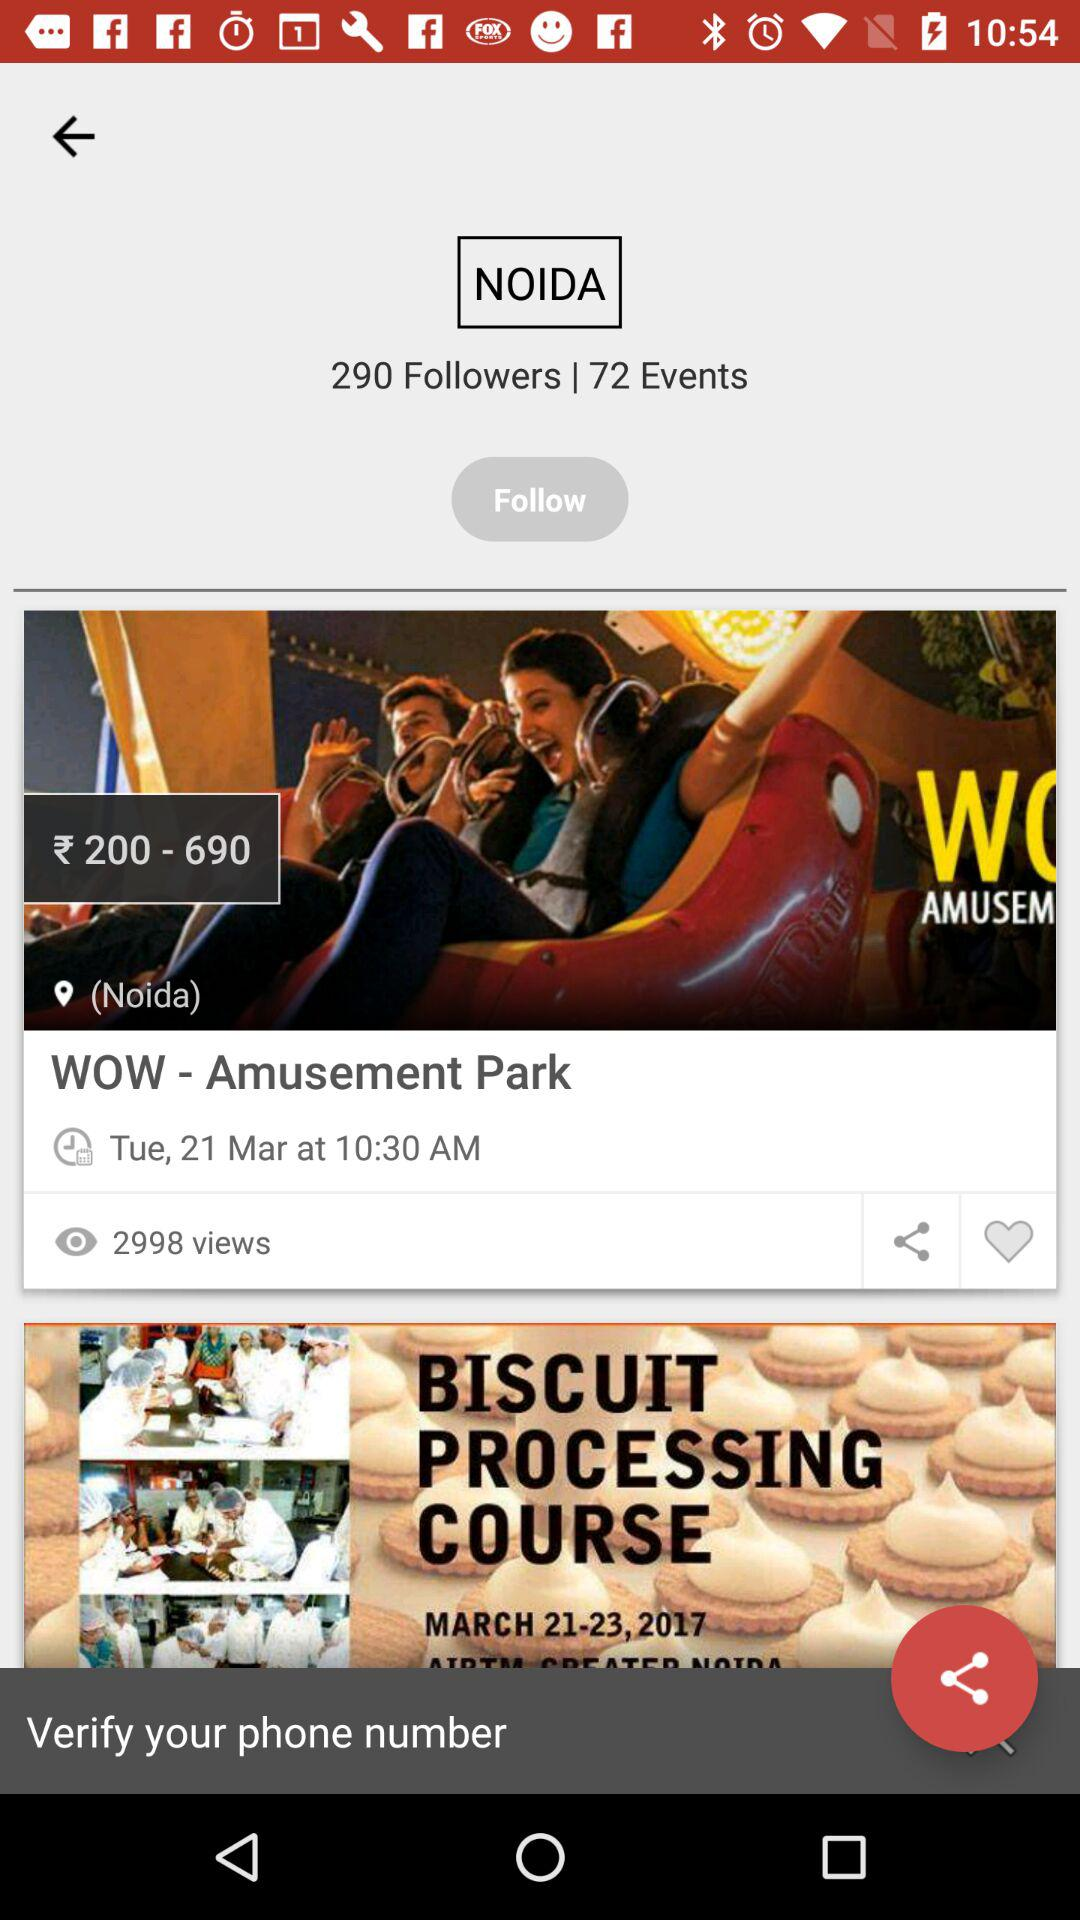How many people does "NOIDA" have as followers? "NOIDA" has 290 followers. 